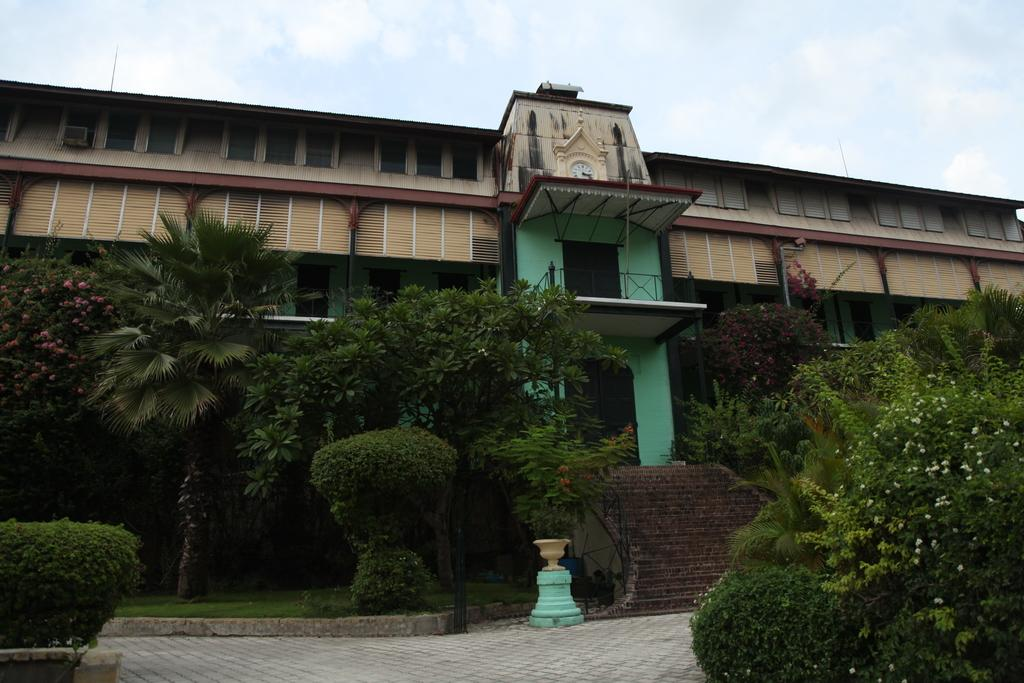What type of structure is visible in the image? There is a building in the image. What can be seen near the building? There are railings, steps, grass, plants, trees, and a pole visible in the image. What is the condition of the sky in the image? The sky is cloudy in the image. How many frogs are sitting on the canvas in the image? There is no canvas or frogs present in the image. What impulse might have led to the creation of the image? We cannot determine the impulse behind the creation of the image from the given facts. 